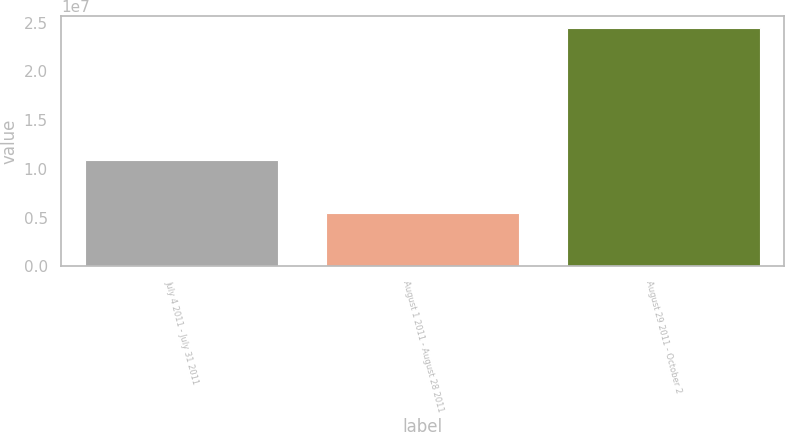Convert chart to OTSL. <chart><loc_0><loc_0><loc_500><loc_500><bar_chart><fcel>July 4 2011 - July 31 2011<fcel>August 1 2011 - August 28 2011<fcel>August 29 2011 - October 2<nl><fcel>1.09295e+07<fcel>5.47486e+06<fcel>2.44463e+07<nl></chart> 